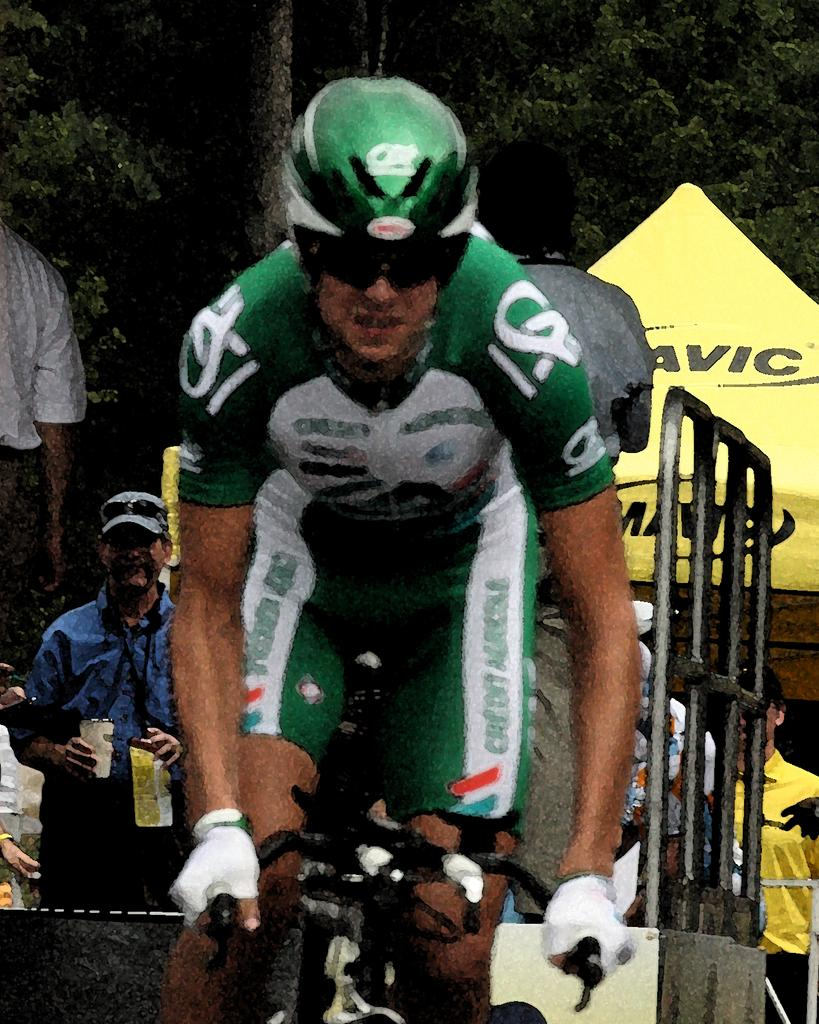What is the man in the image doing? The man is cycling in the image. What is the man wearing while cycling? The man is wearing a green and white color dress and a green helmet. What can be seen in the background of the image? There is a grille, people, a shelter, and trees in the background of the image. What type of celery is the man holding while cycling in the image? There is no celery present in the image; the man is cycling and wearing a green and white color dress and a green helmet. 